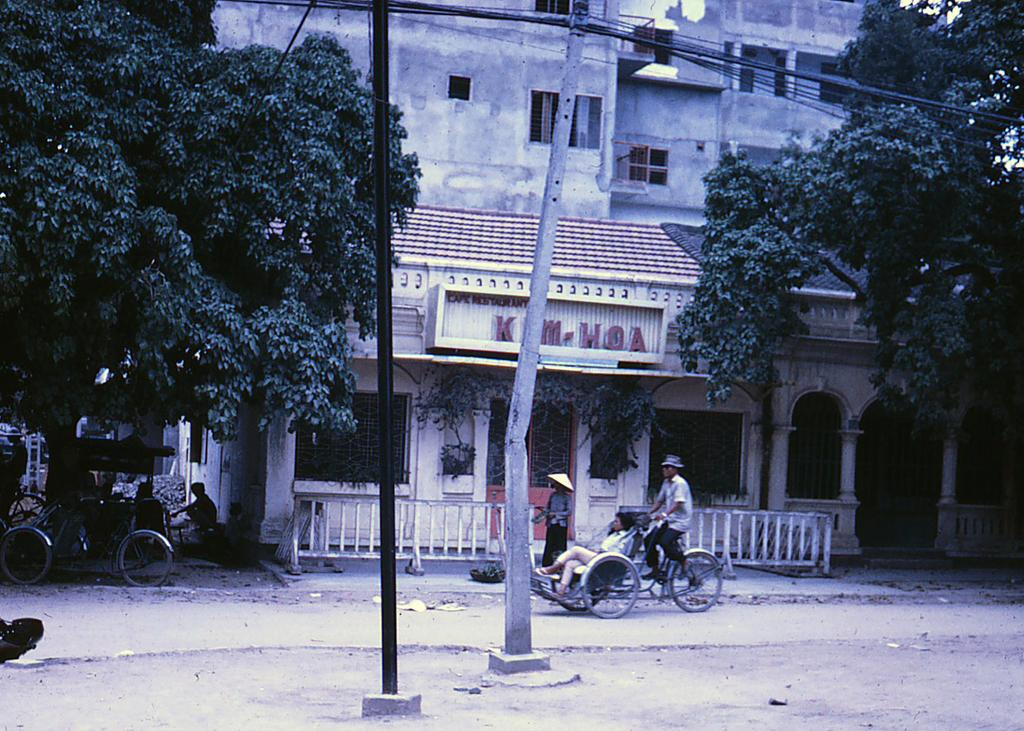What type of natural elements can be seen in the image? There are trees in the image. What type of man-made structures are present in the image? There are buildings in the image. What type of vertical structures can be seen in the image? There are poles in the image. What type of signage is present in the image? There are name boards in the image. What type of cooking equipment can be seen in the image? There are grills in the image. Are there any people visible in the image? Yes, there are persons in the image. What type of transportation infrastructure is present in the image? There is a road in the image. What type of mobile carts are present in the image? There are carts in the image. What type of acoustics can be heard in the image? The image is a visual representation and does not have any audible elements, so it is not possible to determine the acoustics. What type of emotion is being expressed by the trees in the image? Trees do not have emotions, so it is not possible to determine the emotion being expressed. 